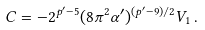<formula> <loc_0><loc_0><loc_500><loc_500>C = - 2 ^ { p ^ { \prime } - 5 } ( 8 \pi ^ { 2 } \alpha ^ { \prime } ) ^ { ( p ^ { \prime } - 9 ) / 2 } V _ { 1 } \, .</formula> 